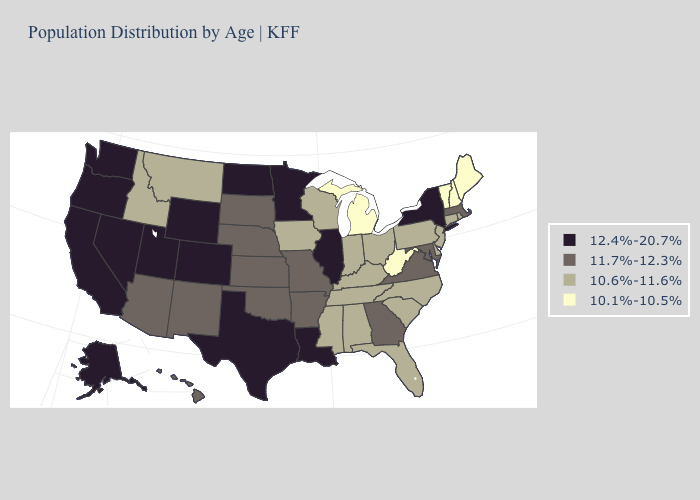Among the states that border North Carolina , does Tennessee have the lowest value?
Write a very short answer. Yes. What is the value of Massachusetts?
Quick response, please. 11.7%-12.3%. Name the states that have a value in the range 12.4%-20.7%?
Be succinct. Alaska, California, Colorado, Illinois, Louisiana, Minnesota, Nevada, New York, North Dakota, Oregon, Texas, Utah, Washington, Wyoming. Name the states that have a value in the range 10.6%-11.6%?
Concise answer only. Alabama, Connecticut, Delaware, Florida, Idaho, Indiana, Iowa, Kentucky, Mississippi, Montana, New Jersey, North Carolina, Ohio, Pennsylvania, Rhode Island, South Carolina, Tennessee, Wisconsin. How many symbols are there in the legend?
Quick response, please. 4. Among the states that border Iowa , which have the highest value?
Short answer required. Illinois, Minnesota. Name the states that have a value in the range 10.1%-10.5%?
Keep it brief. Maine, Michigan, New Hampshire, Vermont, West Virginia. What is the highest value in the USA?
Concise answer only. 12.4%-20.7%. Name the states that have a value in the range 10.6%-11.6%?
Concise answer only. Alabama, Connecticut, Delaware, Florida, Idaho, Indiana, Iowa, Kentucky, Mississippi, Montana, New Jersey, North Carolina, Ohio, Pennsylvania, Rhode Island, South Carolina, Tennessee, Wisconsin. What is the value of Massachusetts?
Keep it brief. 11.7%-12.3%. Name the states that have a value in the range 10.6%-11.6%?
Write a very short answer. Alabama, Connecticut, Delaware, Florida, Idaho, Indiana, Iowa, Kentucky, Mississippi, Montana, New Jersey, North Carolina, Ohio, Pennsylvania, Rhode Island, South Carolina, Tennessee, Wisconsin. Name the states that have a value in the range 11.7%-12.3%?
Concise answer only. Arizona, Arkansas, Georgia, Hawaii, Kansas, Maryland, Massachusetts, Missouri, Nebraska, New Mexico, Oklahoma, South Dakota, Virginia. Name the states that have a value in the range 10.6%-11.6%?
Answer briefly. Alabama, Connecticut, Delaware, Florida, Idaho, Indiana, Iowa, Kentucky, Mississippi, Montana, New Jersey, North Carolina, Ohio, Pennsylvania, Rhode Island, South Carolina, Tennessee, Wisconsin. Does California have the same value as Indiana?
Write a very short answer. No. Which states have the highest value in the USA?
Be succinct. Alaska, California, Colorado, Illinois, Louisiana, Minnesota, Nevada, New York, North Dakota, Oregon, Texas, Utah, Washington, Wyoming. 